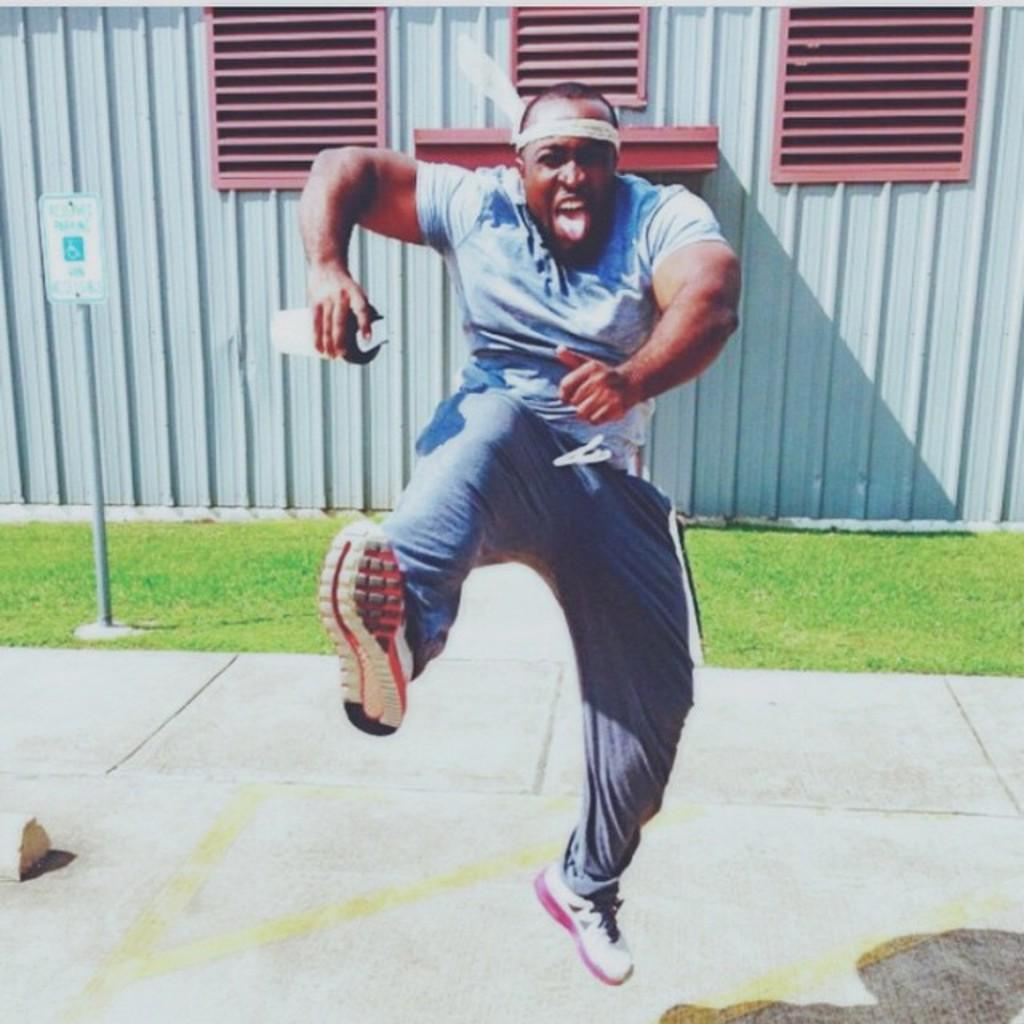What is the main subject of the image? There is a man in the image. What is the man holding in his hand? The man is holding a bottle in his hand. What can be seen behind the man? There is a sign board behind the man. What material is the metal rod made of? The metal rod is made of metal. What type of vegetation is present in the image? Grass is present in the image. How many grandfathers are present in the image? There is no mention of a grandfather in the image, so it cannot be determined if any are present. What shape is the flock of birds in the image? There is no flock of birds present in the image. 